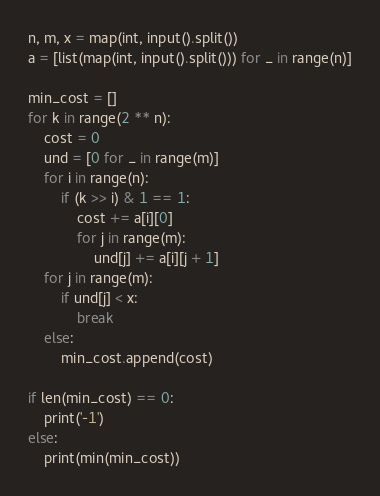<code> <loc_0><loc_0><loc_500><loc_500><_Python_>n, m, x = map(int, input().split())
a = [list(map(int, input().split())) for _ in range(n)]

min_cost = []
for k in range(2 ** n):
    cost = 0
    und = [0 for _ in range(m)]
    for i in range(n):
        if (k >> i) & 1 == 1:
            cost += a[i][0]
            for j in range(m):
                und[j] += a[i][j + 1]
    for j in range(m):
        if und[j] < x:
            break
    else:
        min_cost.append(cost)

if len(min_cost) == 0:
    print('-1')
else:
    print(min(min_cost))</code> 